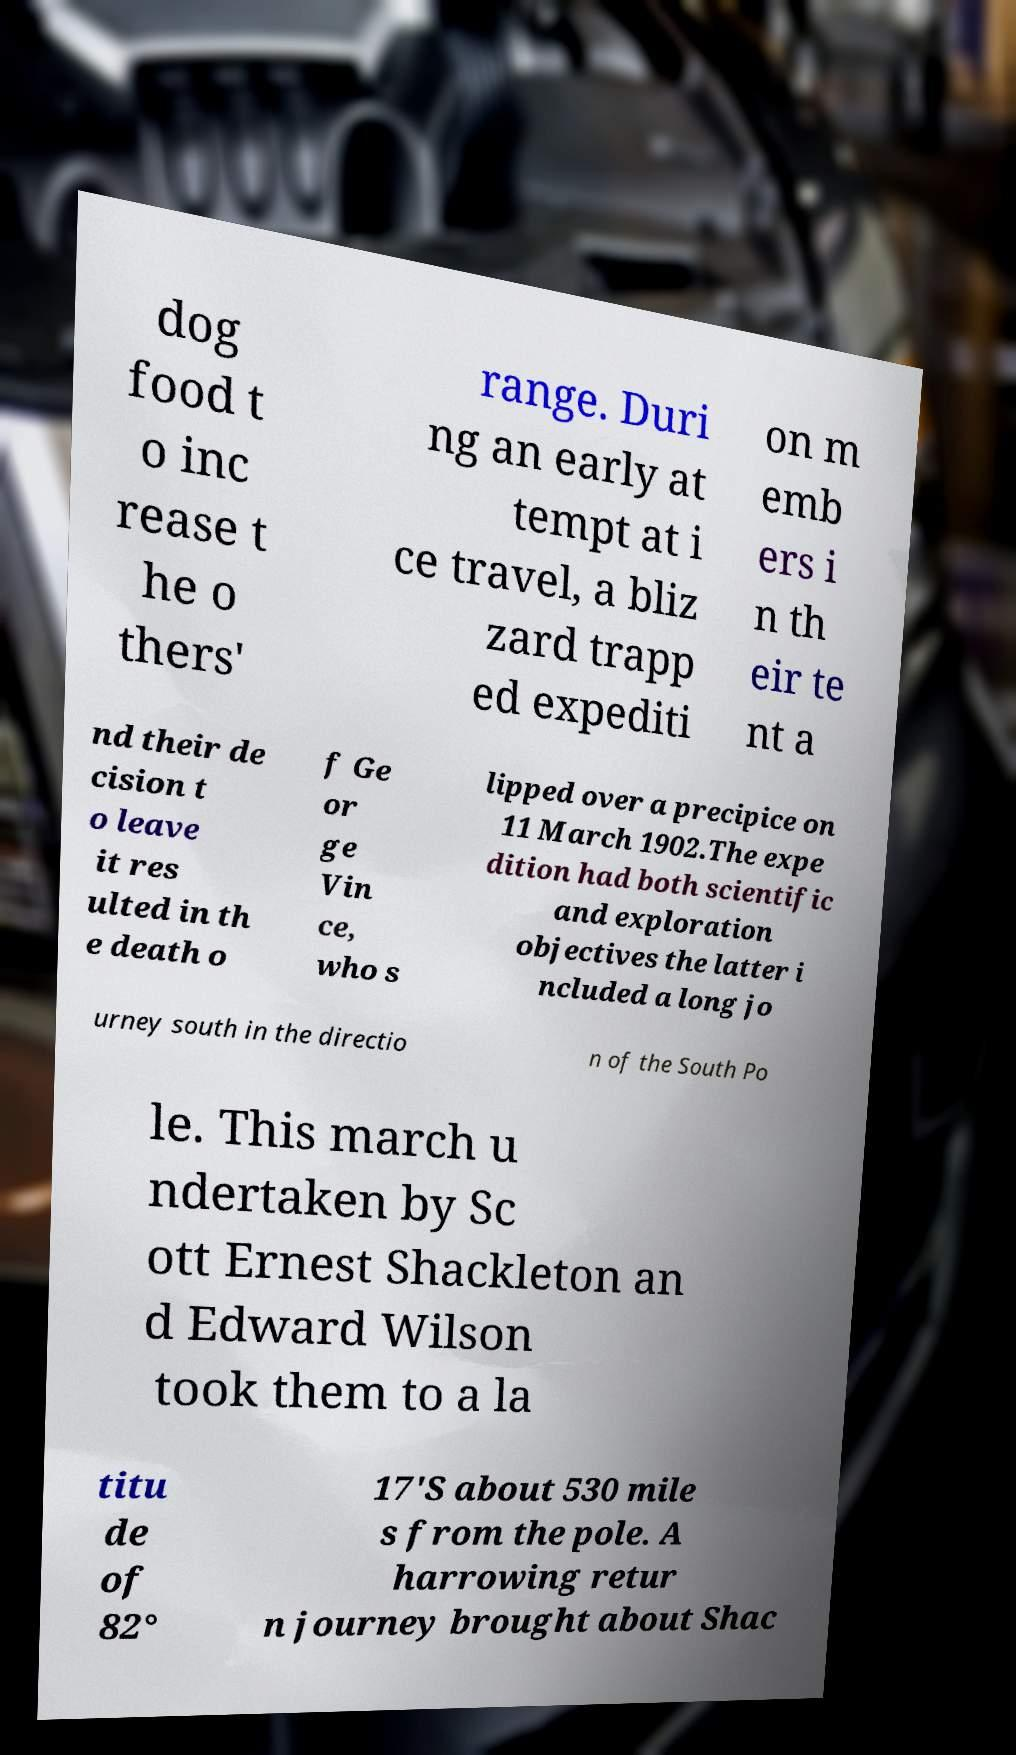Please identify and transcribe the text found in this image. dog food t o inc rease t he o thers' range. Duri ng an early at tempt at i ce travel, a bliz zard trapp ed expediti on m emb ers i n th eir te nt a nd their de cision t o leave it res ulted in th e death o f Ge or ge Vin ce, who s lipped over a precipice on 11 March 1902.The expe dition had both scientific and exploration objectives the latter i ncluded a long jo urney south in the directio n of the South Po le. This march u ndertaken by Sc ott Ernest Shackleton an d Edward Wilson took them to a la titu de of 82° 17′S about 530 mile s from the pole. A harrowing retur n journey brought about Shac 